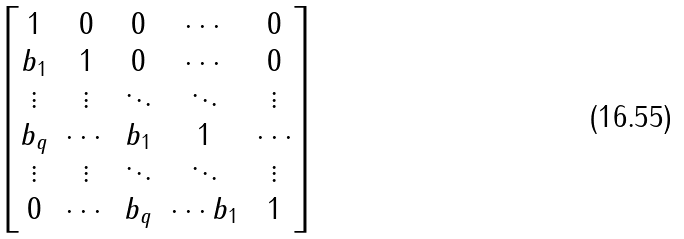<formula> <loc_0><loc_0><loc_500><loc_500>\begin{bmatrix} 1 & 0 & 0 & \cdots & 0 \\ b _ { 1 } & 1 & 0 & \cdots & 0 \\ \vdots & \vdots & \ddots & \ddots & \vdots \\ b _ { q } & \cdots & b _ { 1 } & 1 & \cdots \\ \vdots & \vdots & \ddots & \ddots & \vdots \\ 0 & \cdots & b _ { q } & \cdots b _ { 1 } & 1 \end{bmatrix}</formula> 